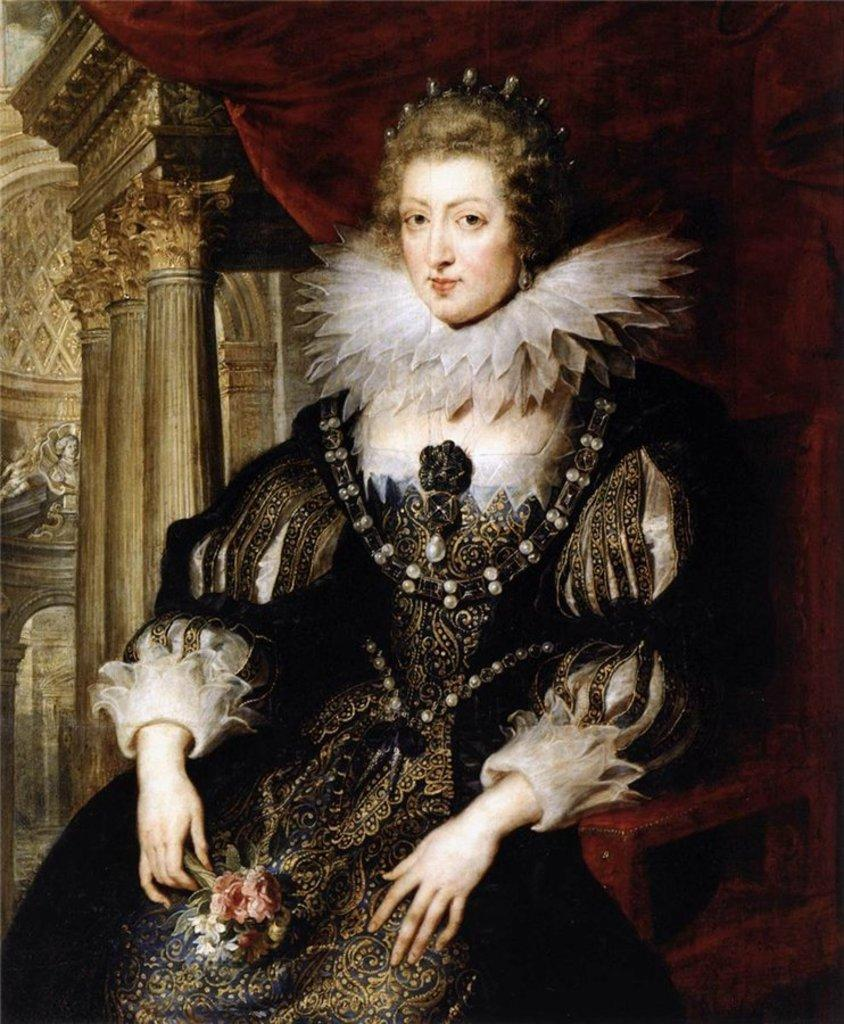What is the main subject of the image? The image contains a painting. What is the painting depicting? The painting depicts a woman. What is the woman doing in the painting? The woman is seated on a chair. How many eyes does the hole in the painting have? There is no hole present in the painting, and therefore no eyes can be attributed to it. 